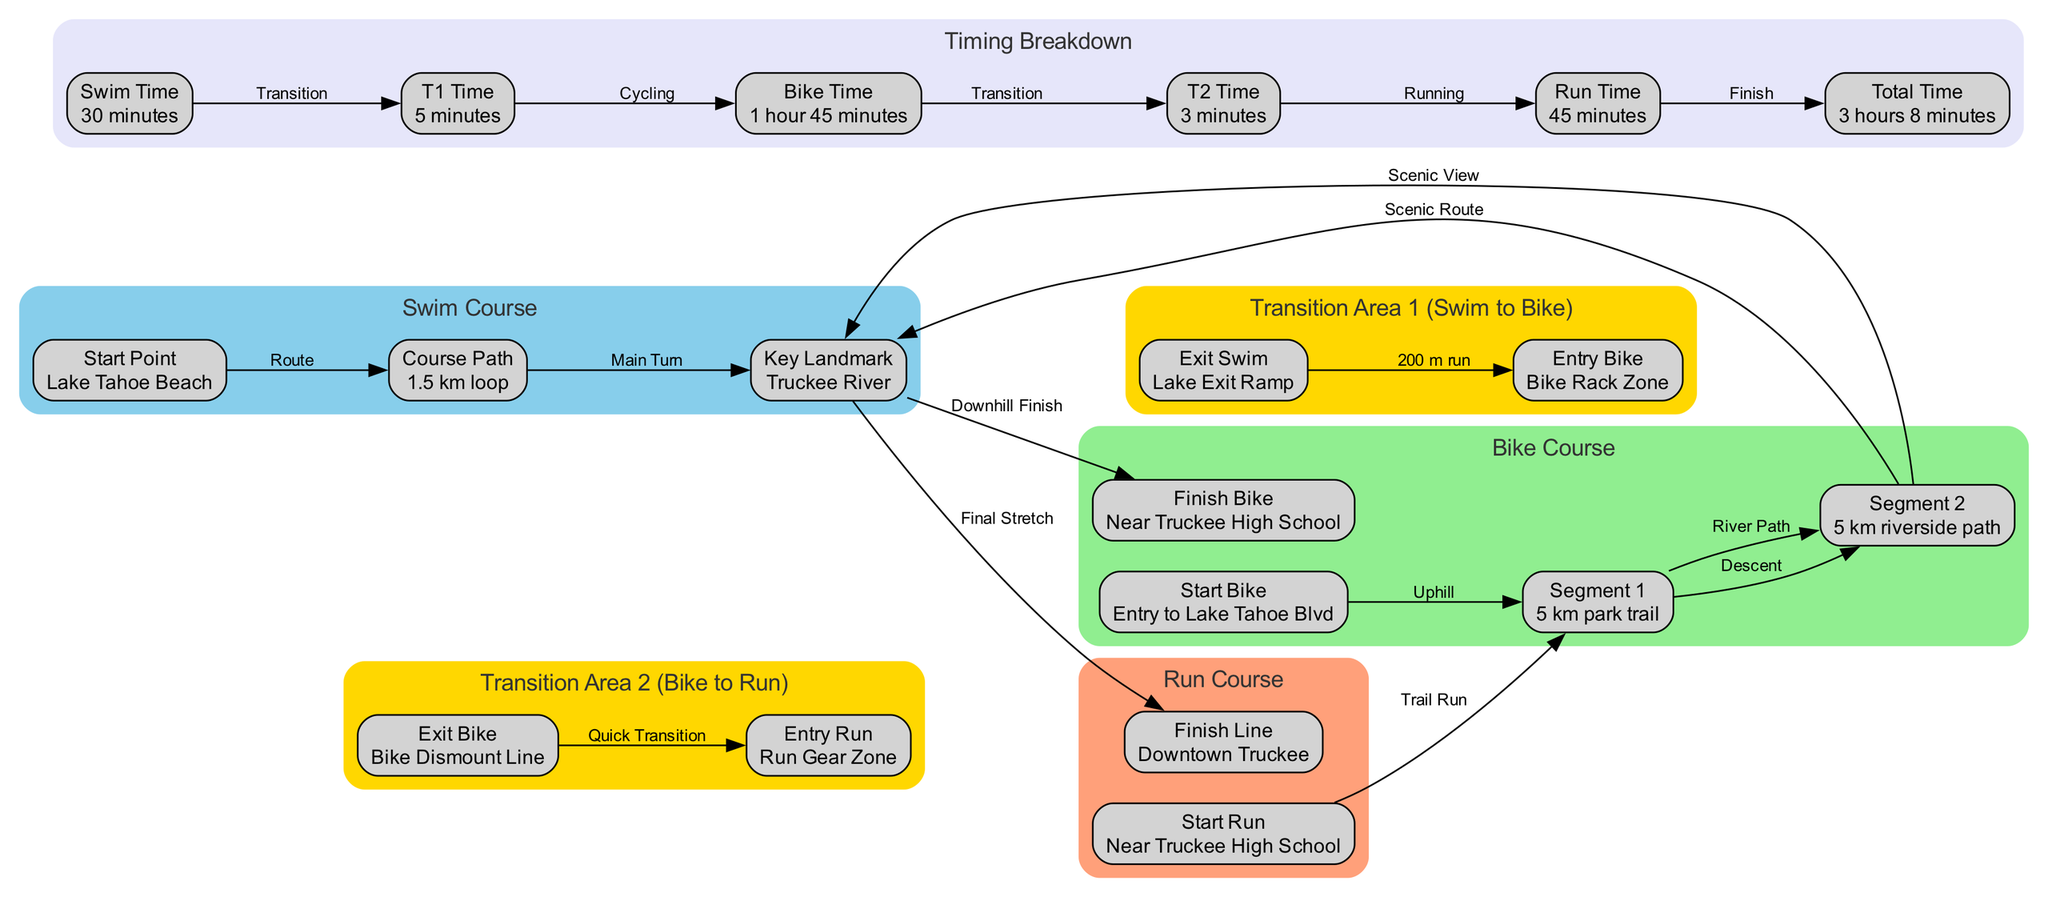What is the total swim distance in the event? The swim course is labeled as a "1.5 km loop." This indicates that the total distance for this section of the triathlon is 1.5 kilometers.
Answer: 1.5 km What does the T1 label represent in the timing breakdown? The T1 label stands for "Transition 1," which is the time taken to transition from the swim to the bike segment. It is specified as "5 minutes" in the timing breakdown.
Answer: 5 minutes How many segments are there in the bike course? The bike course is divided into three segments: "Segment 1" (20 km climb), "Segment 2" (30 km downhill), and the bike "Finish" near Truckee High School. Overall, the course layout includes two main segments plus the finish.
Answer: 3 What is the key landmark on the bike course? The key landmark on the bike course is labeled as "Donner Pass." It serves as a significant point of reference along this segment.
Answer: Donner Pass What is the total time taken for the event? The total time for the triathlon is noted in the timing breakdown as "3 hours 8 minutes." This is calculated by summing the times from all segments including transition times.
Answer: 3 hours 8 minutes What is the distance of the run course? The run course consists of two segments: "Segment 1" is a 5 km park trail, and "Segment 2" is a 5 km riverside path, totaling 10 kilometers for the run segment.
Answer: 10 km What is the connection between the Exit Swim and Entry Bike nodes? The Exit Swim node leads to the Entry Bike node and is labeled as a "200 m run," indicating the distance participants must run during this transition.
Answer: 200 m run How long does it take for the runner to complete the run segment? The time taken to complete the run segment is labeled "Run Time" as "45 minutes" in the timing breakdown. This indicates the duration for this part of the triathlon.
Answer: 45 minutes What is the Start Point of the swim course? The Start Point of the swim course is labeled as "Lake Tahoe Beach." This is where participants begin their swimming segment.
Answer: Lake Tahoe Beach 